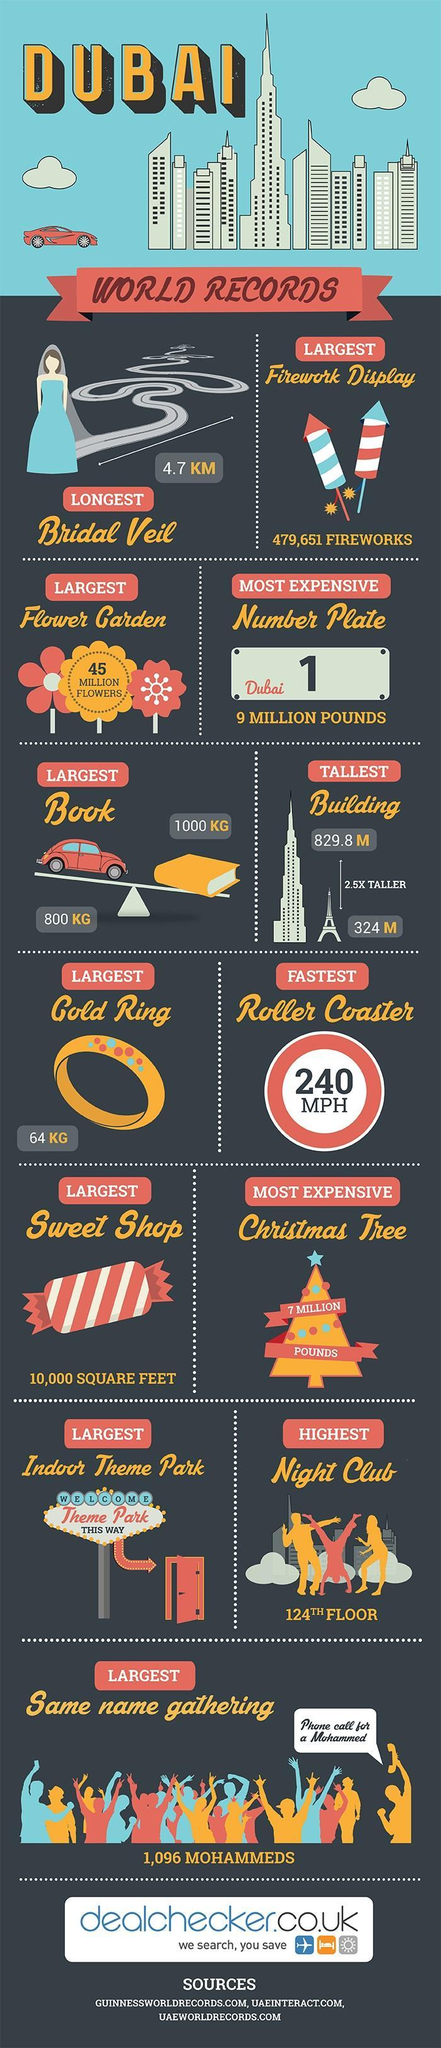What is the height difference in M between Burj Khalifa and Eifel towers
Answer the question with a short phrase. 505.8 What is the speed of the roller coaster 240 MPH What is written on the number plate Dubai 1 How much heavier in kgs is the largest book than a car 200 What was the name in the same name gathering MOhammed the weight of the book was compared to what, car or bus car What is written on the sign board Welcome, Theme Park, This Way What was the cost of the Number Plate Dubai 1 9 million pounds What is the colour of the dress of the bride, blue or white blue 